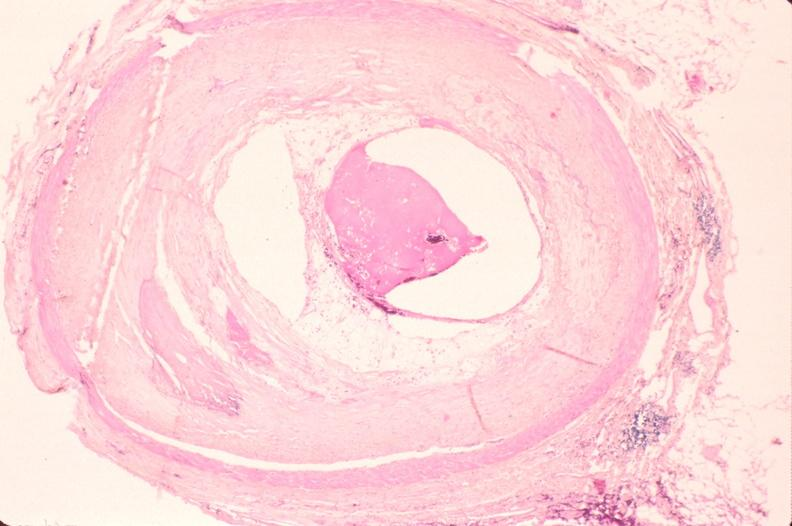does chronic ischemia show atherosclerosis?
Answer the question using a single word or phrase. No 